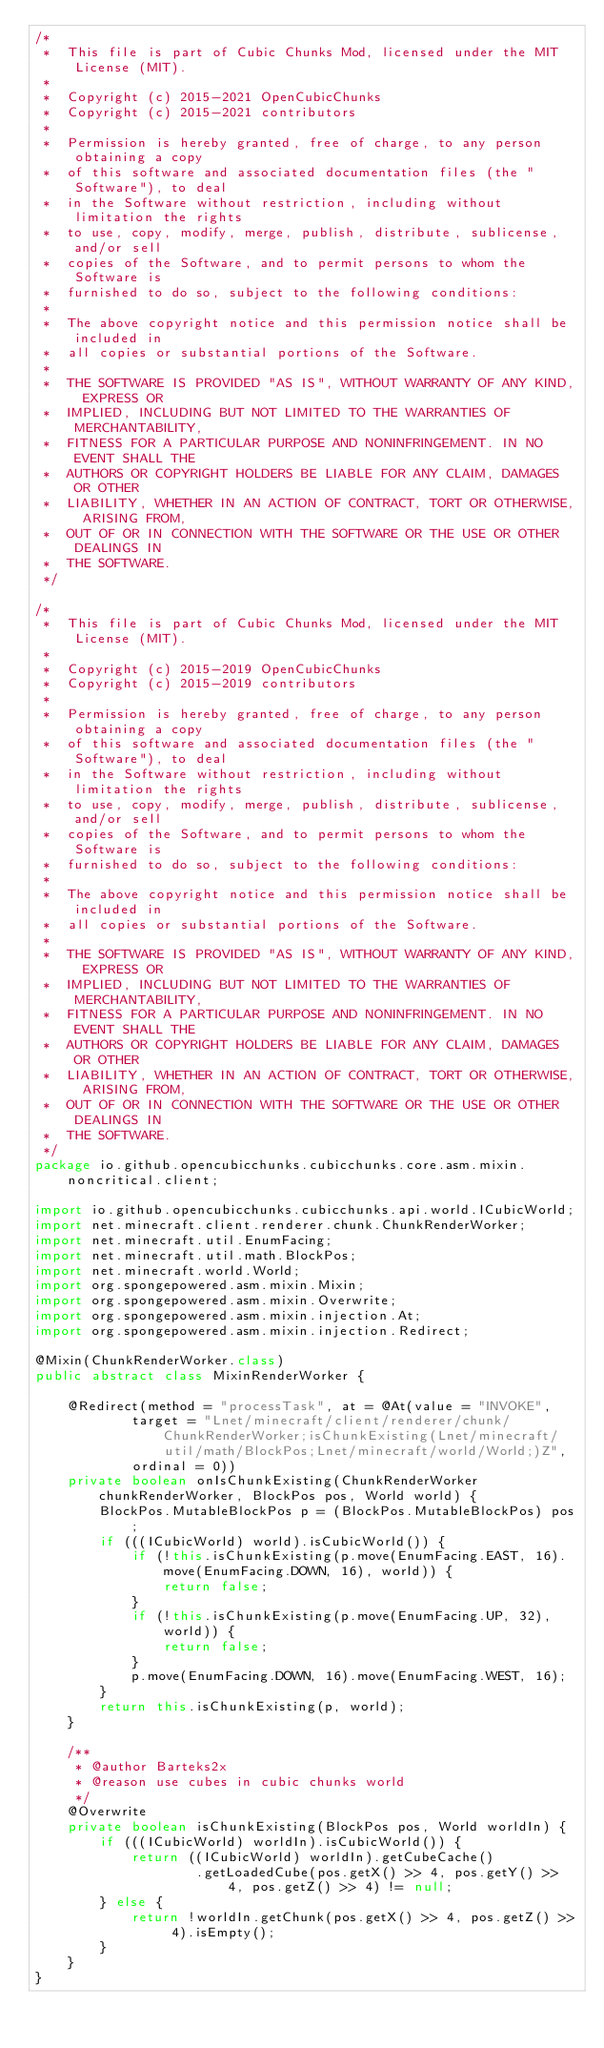Convert code to text. <code><loc_0><loc_0><loc_500><loc_500><_Java_>/*
 *  This file is part of Cubic Chunks Mod, licensed under the MIT License (MIT).
 *
 *  Copyright (c) 2015-2021 OpenCubicChunks
 *  Copyright (c) 2015-2021 contributors
 *
 *  Permission is hereby granted, free of charge, to any person obtaining a copy
 *  of this software and associated documentation files (the "Software"), to deal
 *  in the Software without restriction, including without limitation the rights
 *  to use, copy, modify, merge, publish, distribute, sublicense, and/or sell
 *  copies of the Software, and to permit persons to whom the Software is
 *  furnished to do so, subject to the following conditions:
 *
 *  The above copyright notice and this permission notice shall be included in
 *  all copies or substantial portions of the Software.
 *
 *  THE SOFTWARE IS PROVIDED "AS IS", WITHOUT WARRANTY OF ANY KIND, EXPRESS OR
 *  IMPLIED, INCLUDING BUT NOT LIMITED TO THE WARRANTIES OF MERCHANTABILITY,
 *  FITNESS FOR A PARTICULAR PURPOSE AND NONINFRINGEMENT. IN NO EVENT SHALL THE
 *  AUTHORS OR COPYRIGHT HOLDERS BE LIABLE FOR ANY CLAIM, DAMAGES OR OTHER
 *  LIABILITY, WHETHER IN AN ACTION OF CONTRACT, TORT OR OTHERWISE, ARISING FROM,
 *  OUT OF OR IN CONNECTION WITH THE SOFTWARE OR THE USE OR OTHER DEALINGS IN
 *  THE SOFTWARE.
 */

/*
 *  This file is part of Cubic Chunks Mod, licensed under the MIT License (MIT).
 *
 *  Copyright (c) 2015-2019 OpenCubicChunks
 *  Copyright (c) 2015-2019 contributors
 *
 *  Permission is hereby granted, free of charge, to any person obtaining a copy
 *  of this software and associated documentation files (the "Software"), to deal
 *  in the Software without restriction, including without limitation the rights
 *  to use, copy, modify, merge, publish, distribute, sublicense, and/or sell
 *  copies of the Software, and to permit persons to whom the Software is
 *  furnished to do so, subject to the following conditions:
 *
 *  The above copyright notice and this permission notice shall be included in
 *  all copies or substantial portions of the Software.
 *
 *  THE SOFTWARE IS PROVIDED "AS IS", WITHOUT WARRANTY OF ANY KIND, EXPRESS OR
 *  IMPLIED, INCLUDING BUT NOT LIMITED TO THE WARRANTIES OF MERCHANTABILITY,
 *  FITNESS FOR A PARTICULAR PURPOSE AND NONINFRINGEMENT. IN NO EVENT SHALL THE
 *  AUTHORS OR COPYRIGHT HOLDERS BE LIABLE FOR ANY CLAIM, DAMAGES OR OTHER
 *  LIABILITY, WHETHER IN AN ACTION OF CONTRACT, TORT OR OTHERWISE, ARISING FROM,
 *  OUT OF OR IN CONNECTION WITH THE SOFTWARE OR THE USE OR OTHER DEALINGS IN
 *  THE SOFTWARE.
 */
package io.github.opencubicchunks.cubicchunks.core.asm.mixin.noncritical.client;

import io.github.opencubicchunks.cubicchunks.api.world.ICubicWorld;
import net.minecraft.client.renderer.chunk.ChunkRenderWorker;
import net.minecraft.util.EnumFacing;
import net.minecraft.util.math.BlockPos;
import net.minecraft.world.World;
import org.spongepowered.asm.mixin.Mixin;
import org.spongepowered.asm.mixin.Overwrite;
import org.spongepowered.asm.mixin.injection.At;
import org.spongepowered.asm.mixin.injection.Redirect;

@Mixin(ChunkRenderWorker.class)
public abstract class MixinRenderWorker {

    @Redirect(method = "processTask", at = @At(value = "INVOKE",
            target = "Lnet/minecraft/client/renderer/chunk/ChunkRenderWorker;isChunkExisting(Lnet/minecraft/util/math/BlockPos;Lnet/minecraft/world/World;)Z",
            ordinal = 0))
    private boolean onIsChunkExisting(ChunkRenderWorker chunkRenderWorker, BlockPos pos, World world) {
        BlockPos.MutableBlockPos p = (BlockPos.MutableBlockPos) pos;
        if (((ICubicWorld) world).isCubicWorld()) {
            if (!this.isChunkExisting(p.move(EnumFacing.EAST, 16).move(EnumFacing.DOWN, 16), world)) {
                return false;
            }
            if (!this.isChunkExisting(p.move(EnumFacing.UP, 32), world)) {
                return false;
            }
            p.move(EnumFacing.DOWN, 16).move(EnumFacing.WEST, 16);
        }
        return this.isChunkExisting(p, world);
    }

    /**
     * @author Barteks2x
     * @reason use cubes in cubic chunks world
     */
    @Overwrite
    private boolean isChunkExisting(BlockPos pos, World worldIn) {
        if (((ICubicWorld) worldIn).isCubicWorld()) {
            return ((ICubicWorld) worldIn).getCubeCache()
                    .getLoadedCube(pos.getX() >> 4, pos.getY() >> 4, pos.getZ() >> 4) != null;
        } else {
            return !worldIn.getChunk(pos.getX() >> 4, pos.getZ() >> 4).isEmpty();
        }
    }
}
</code> 